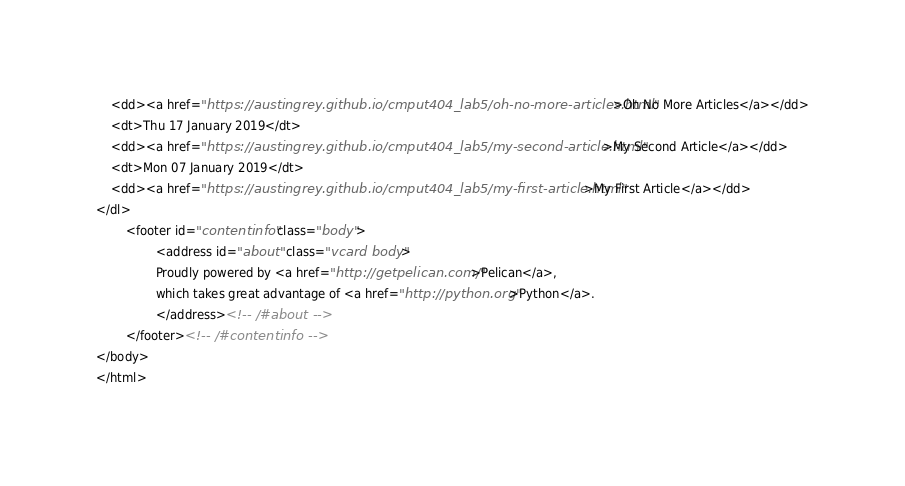<code> <loc_0><loc_0><loc_500><loc_500><_HTML_>    <dd><a href="https://austingrey.github.io/cmput404_lab5/oh-no-more-articles.html">Oh No More Articles</a></dd>
    <dt>Thu 17 January 2019</dt>
    <dd><a href="https://austingrey.github.io/cmput404_lab5/my-second-article.html">My Second Article</a></dd>
    <dt>Mon 07 January 2019</dt>
    <dd><a href="https://austingrey.github.io/cmput404_lab5/my-first-article.html">My First Article</a></dd>
</dl>
        <footer id="contentinfo" class="body">
                <address id="about" class="vcard body">
                Proudly powered by <a href="http://getpelican.com/">Pelican</a>,
                which takes great advantage of <a href="http://python.org">Python</a>.
                </address><!-- /#about -->
        </footer><!-- /#contentinfo -->
</body>
</html></code> 